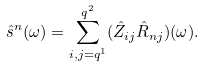<formula> <loc_0><loc_0><loc_500><loc_500>\hat { s } ^ { n } ( \omega ) = \sum _ { i , j = q ^ { 1 } } ^ { q ^ { 2 } } ( \hat { Z } _ { i j } \hat { R } _ { n j } ) ( \omega ) .</formula> 